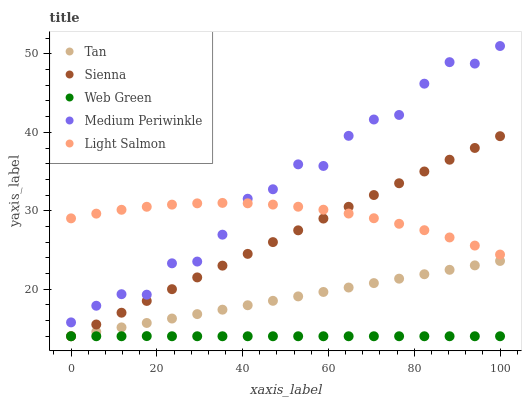Does Web Green have the minimum area under the curve?
Answer yes or no. Yes. Does Medium Periwinkle have the maximum area under the curve?
Answer yes or no. Yes. Does Tan have the minimum area under the curve?
Answer yes or no. No. Does Tan have the maximum area under the curve?
Answer yes or no. No. Is Sienna the smoothest?
Answer yes or no. Yes. Is Medium Periwinkle the roughest?
Answer yes or no. Yes. Is Tan the smoothest?
Answer yes or no. No. Is Tan the roughest?
Answer yes or no. No. Does Sienna have the lowest value?
Answer yes or no. Yes. Does Medium Periwinkle have the lowest value?
Answer yes or no. No. Does Medium Periwinkle have the highest value?
Answer yes or no. Yes. Does Tan have the highest value?
Answer yes or no. No. Is Web Green less than Light Salmon?
Answer yes or no. Yes. Is Light Salmon greater than Tan?
Answer yes or no. Yes. Does Sienna intersect Light Salmon?
Answer yes or no. Yes. Is Sienna less than Light Salmon?
Answer yes or no. No. Is Sienna greater than Light Salmon?
Answer yes or no. No. Does Web Green intersect Light Salmon?
Answer yes or no. No. 